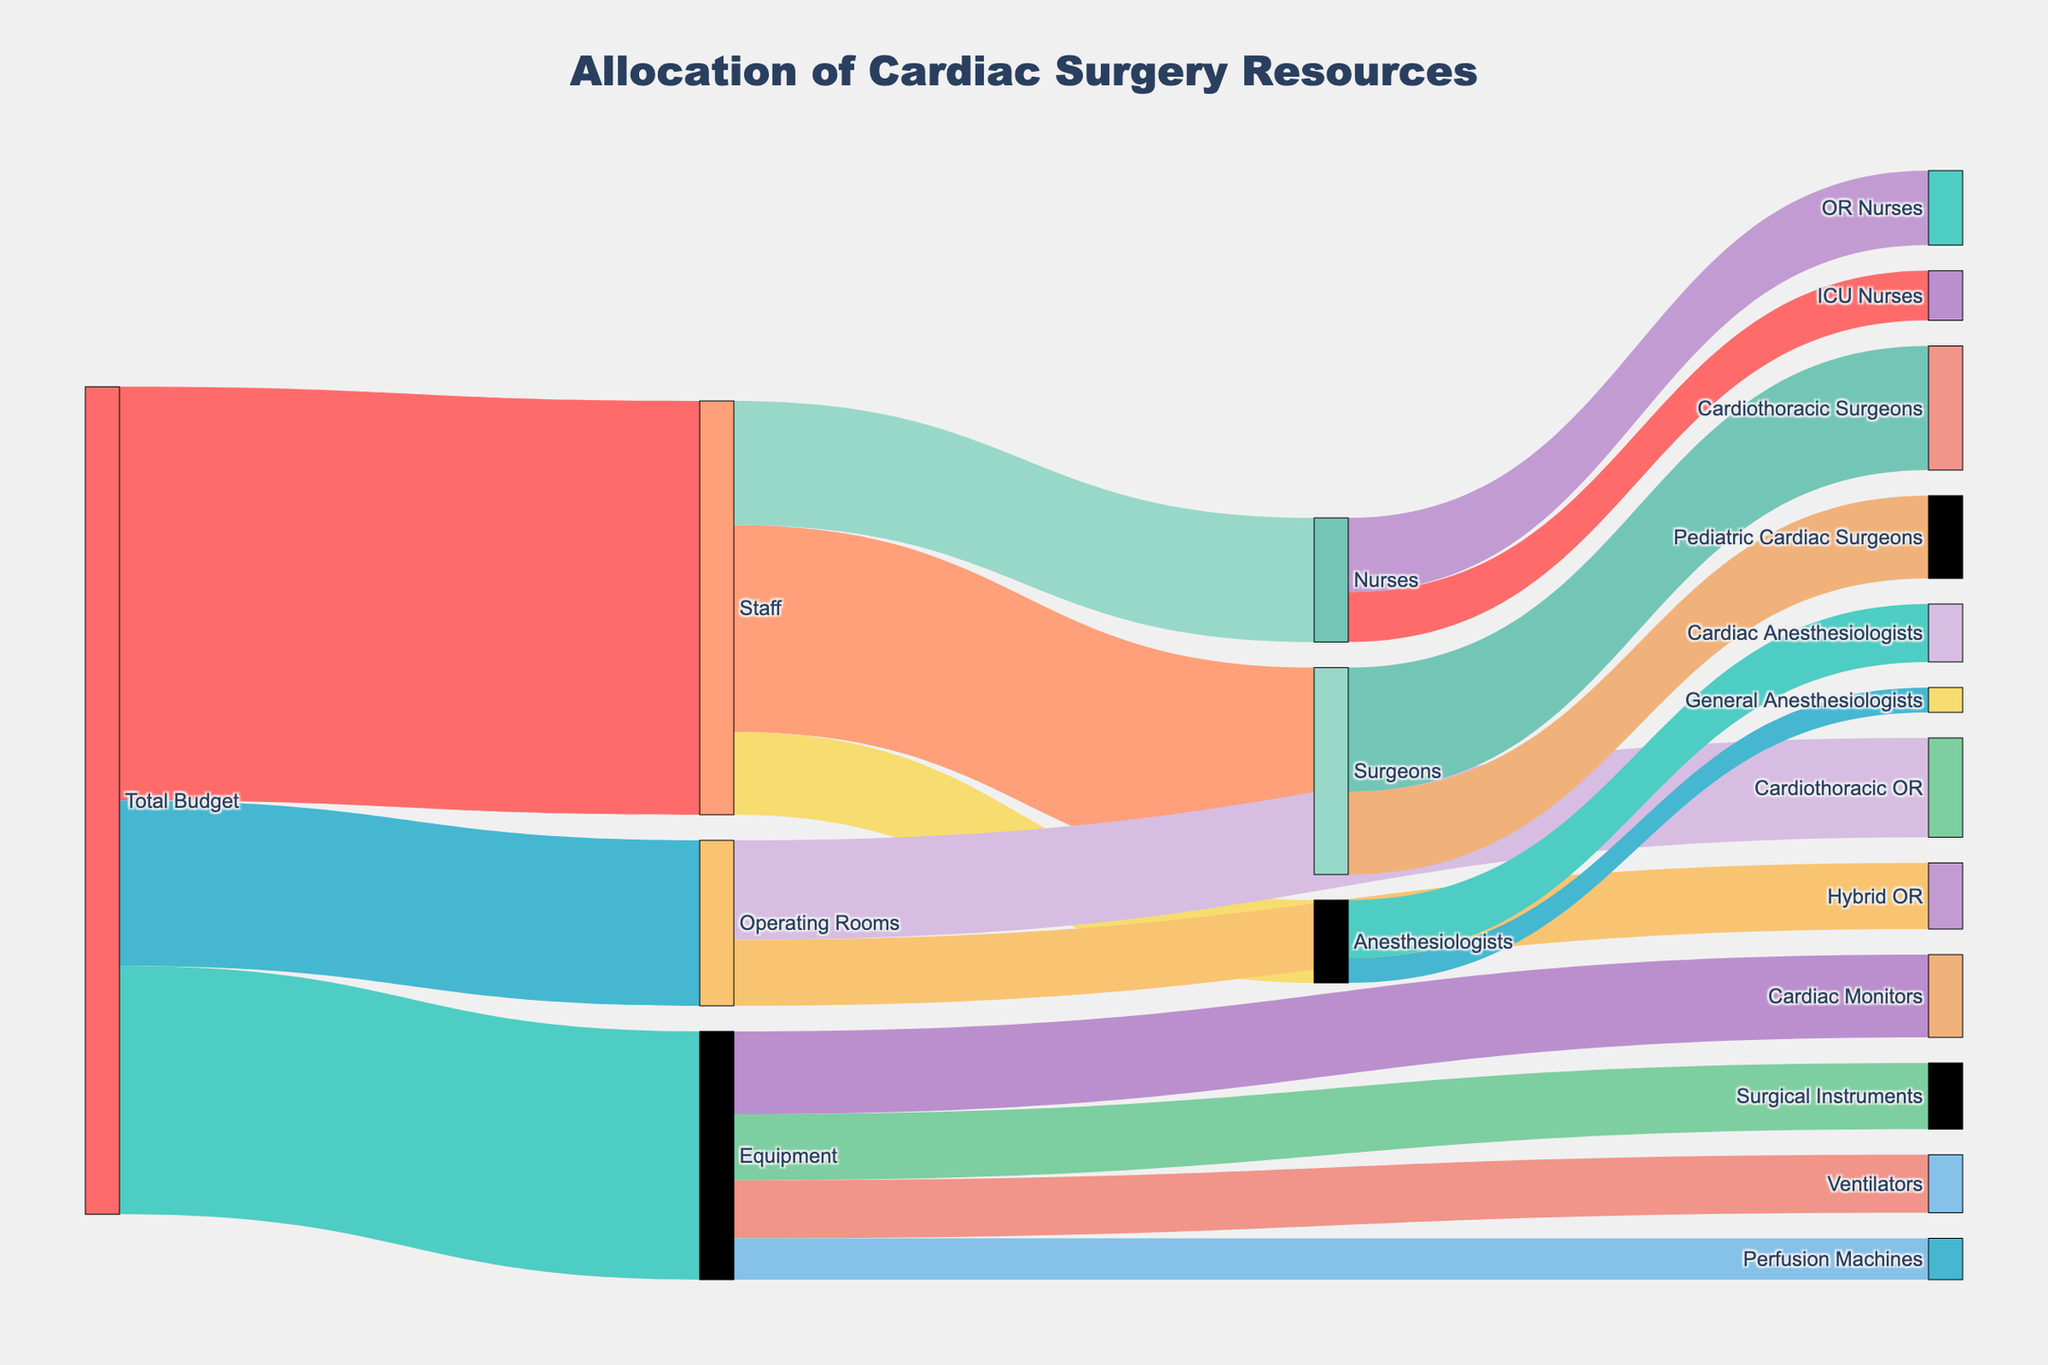What is the highest allocation from the 'Total Budget'? The highest allocation from the 'Total Budget' is determined by examining the values directed from 'Total Budget' to 'Staff,' 'Equipment,' and 'Operating Rooms.' The highest allocation is $5,000,000 to 'Staff.'
Answer: $5,000,000 How much budget is allocated to 'Operating Rooms' compared to 'Equipment'? The allocation to 'Operating Rooms' is $2,000,000, while the allocation to 'Equipment' is $3,000,000. Therefore, 'Equipment' receives $1,000,000 more than 'Operating Rooms.'
Answer: $1,000,000 more What percentage of the 'Total Budget' is allocated to 'Staff'? The 'Total Budget' is $10,000,000. The allocation to 'Staff' is $5,000,000. Thus, the percentage is (5,000,000 / 10,000,000) * 100 = 50%.
Answer: 50% Which type of 'Surgeons' receives a greater budget, 'Cardiothoracic Surgeons' or 'Pediatric Cardiac Surgeons'? From the figure, 'Cardiothoracic Surgeons' receive $1,500,000 and 'Pediatric Cardiac Surgeons' receive $1,000,000. 'Cardiothoracic Surgeons' receive a greater budget.
Answer: Cardiothoracic Surgeons What is the combined budget allocated to all categories under 'Staff'? The combined budget for 'Surgeons,' 'Nurses,' and 'Anesthesiologists' under 'Staff' is $2,500,000 (Surgeons) + $1,500,000 (Nurses) + $1,000,000 (Anesthesiologists) = $5,000,000.
Answer: $5,000,000 Which specific 'Equipment' item receives the least allocation? The specific 'Equipment' item with the least allocation is 'Perfusion Machines' with $500,000.
Answer: Perfusion Machines How much more is allocated to 'Cardiac Monitors' compared to 'Perfusion Machines'? 'Cardiac Monitors' have an allocation of $1,000,000, and 'Perfusion Machines' have $500,000. The difference is $1,000,000 - $500,000 = $500,000.
Answer: $500,000 What is the total allocation for 'Nurses' in the 'Staff' category? The total allocation for 'Nurses' includes 'OR Nurses' ($900,000) and 'ICU Nurses' ($600,000). Therefore, the total is $900,000 + $600,000 = $1,500,000.
Answer: $1,500,000 Which category under 'Operating Rooms' receives more funding, 'Cardiothoracic OR' or 'Hybrid OR'? 'Cardiothoracic OR' receives $1,200,000 and 'Hybrid OR' receives $800,000. Therefore, 'Cardiothoracic OR' receives more funding.
Answer: Cardiothoracic OR What is the smallest allocation in any sub-category of 'Staff'? The smallest allocation in any sub-category of 'Staff' is for 'General Anesthesiologists' under 'Anesthesiologists,' with $300,000.
Answer: General Anesthesiologists 